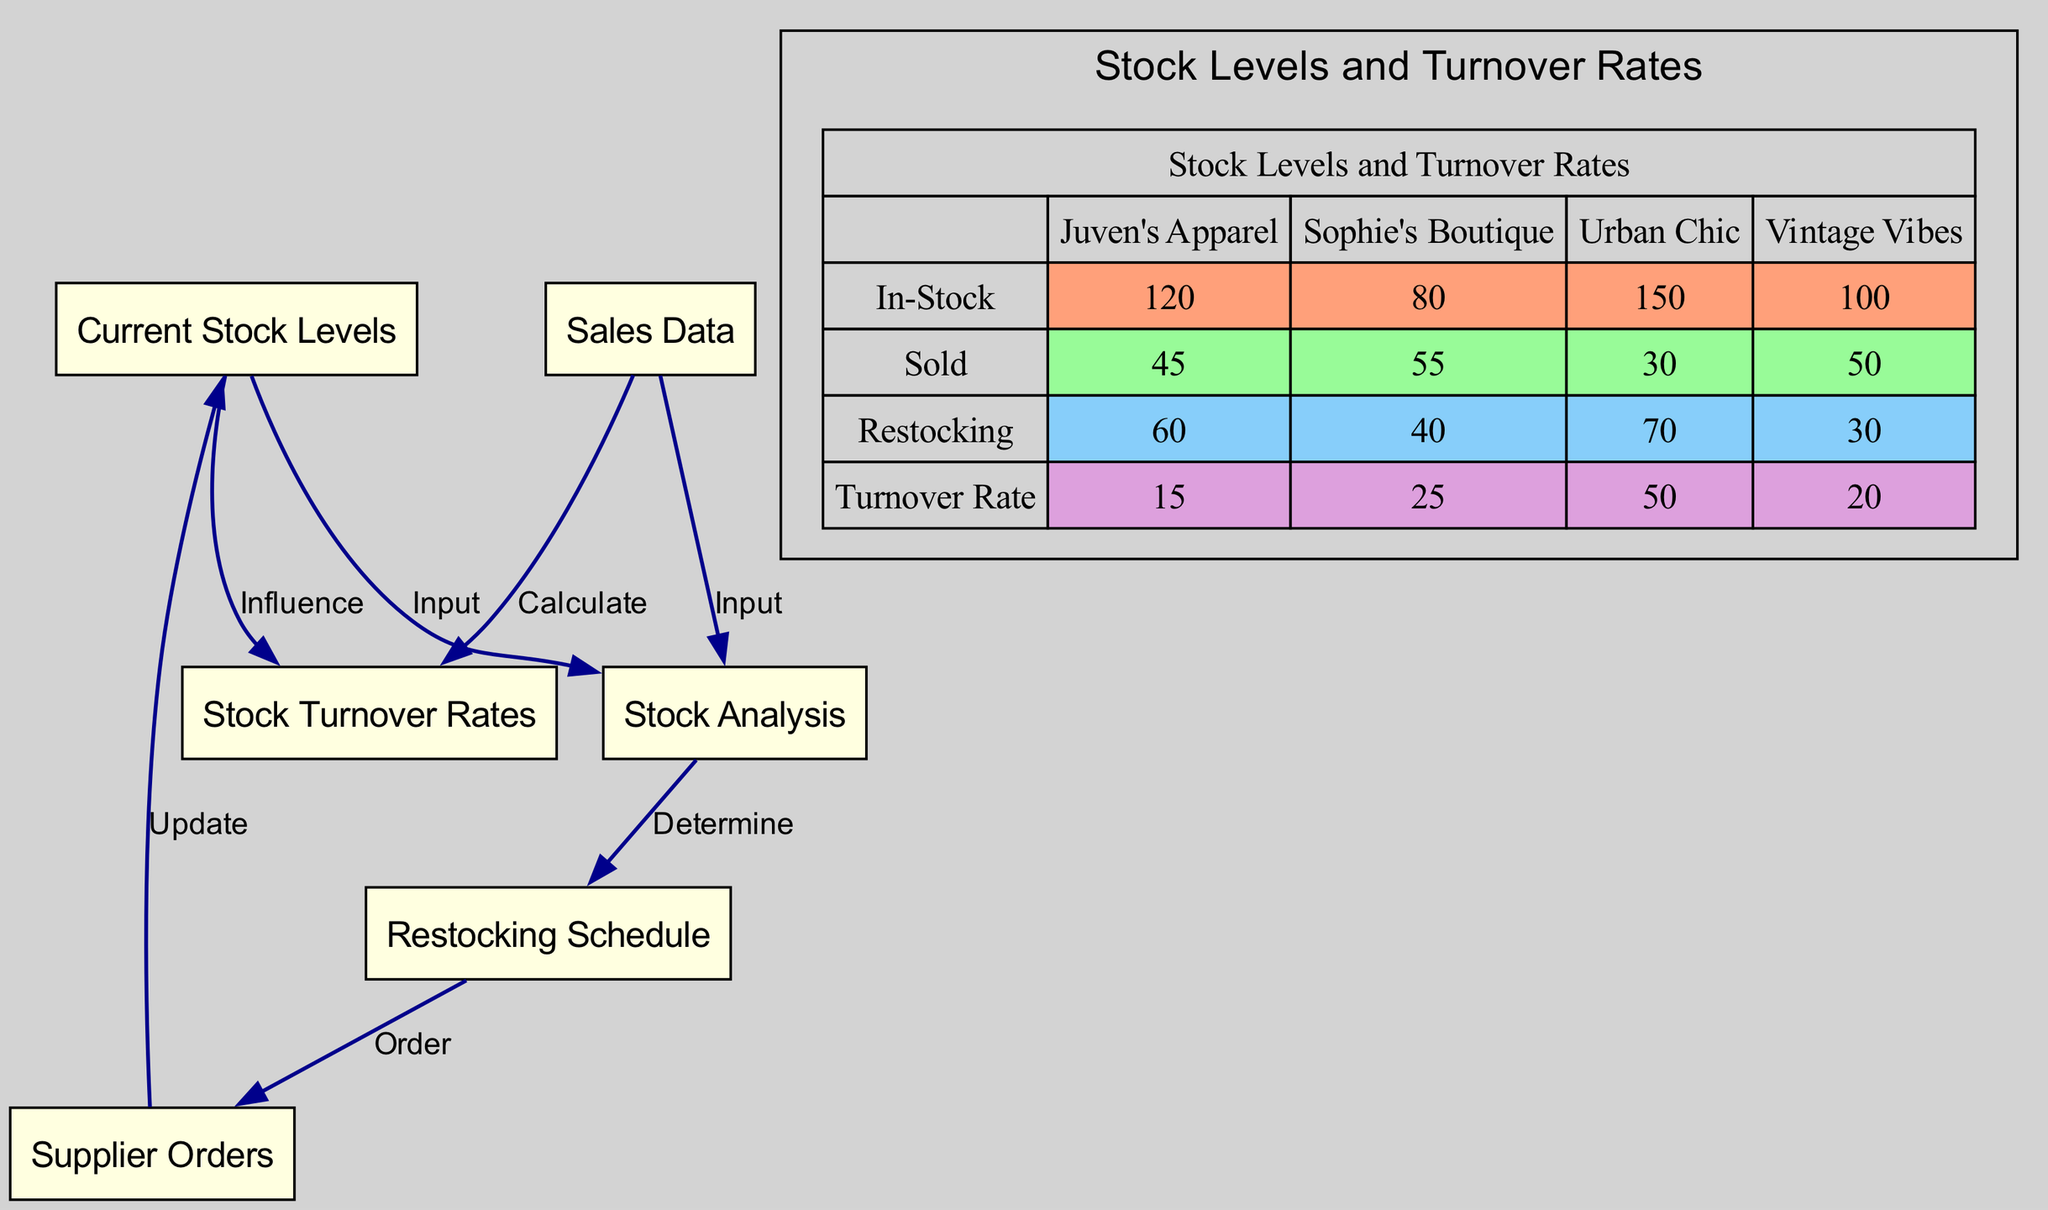What are the current stock levels? The current stock levels represented in the diagram indicate quantities for various boutiques. From the stacked bar diagram, the current stock levels are 120 for Juven's Apparel, 80 for Sophie's Boutique, 150 for Urban Chic, and 100 for Vintage Vibes.
Answer: 120, 80, 150, 100 How many nodes are in the flowchart? The flowchart contains a total of six nodes: Current Stock Levels, Sales Data, Stock Analysis, Restocking Schedule, Stock Turnover Rates, and Supplier Orders. By counting these nodes in the diagram, we arrive at this total.
Answer: 6 Which node influences stock turnover rates? The node that influences stock turnover rates is Current Stock Levels. This is indicated by the direct edge linking them in the flowchart.
Answer: Current Stock Levels What series has the highest sold value? The series with the highest sold value is Juven's Apparel, which has a sold value of 45. We can determine this by comparing the 'Sold' data across the stacked bar chart.
Answer: Juven's Apparel What is the turnover rate for Sophie's Boutique? The turnover rate for Sophie's Boutique is 25, which is clearly indicated in the stacked bar diagram under the Turnover Rate series for Sophie's Boutique.
Answer: 25 How many edges are there in the flowchart? The flowchart contains a total of six edges that represent the relationships and flow between the nodes. This information comes directly from counting the edges listed in the flowchart section of the diagram.
Answer: 6 Which boutique has the lowest restocking value? The boutique with the lowest restocking value is Vintage Vibes, which has a restocking value of 30. This can be observed in the Restocking series of the stacked bar chart.
Answer: Vintage Vibes Which two nodes both provide input to stock analysis? The two nodes that provide input to stock analysis are Current Stock Levels and Sales Data. This is evident from the flow chart connections leading to the Stock Analysis node.
Answer: Current Stock Levels, Sales Data What is the in-stock value for Urban Chic? The in-stock value for Urban Chic is 150, as seen in the 'In-Stock' series of the stacked bar diagram.
Answer: 150 